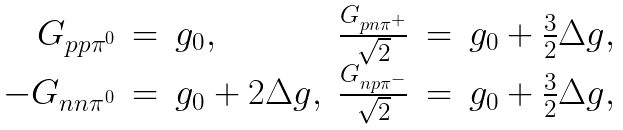<formula> <loc_0><loc_0><loc_500><loc_500>\begin{array} { r c l r c l } { { G _ { p p \pi ^ { 0 } } } } & { = } & { { g _ { 0 } , } } & { { \frac { G _ { p n \pi ^ { + } } } { \sqrt { 2 } } } } & { = } & { { g _ { 0 } + \frac { 3 } { 2 } \Delta g , } } \\ { { - G _ { n n \pi ^ { 0 } } } } & { = } & { { g _ { 0 } + 2 \Delta g , } } & { { \frac { G _ { n p \pi ^ { - } } } { \sqrt { 2 } } } } & { = } & { { g _ { 0 } + \frac { 3 } { 2 } \Delta g , } } \end{array}</formula> 